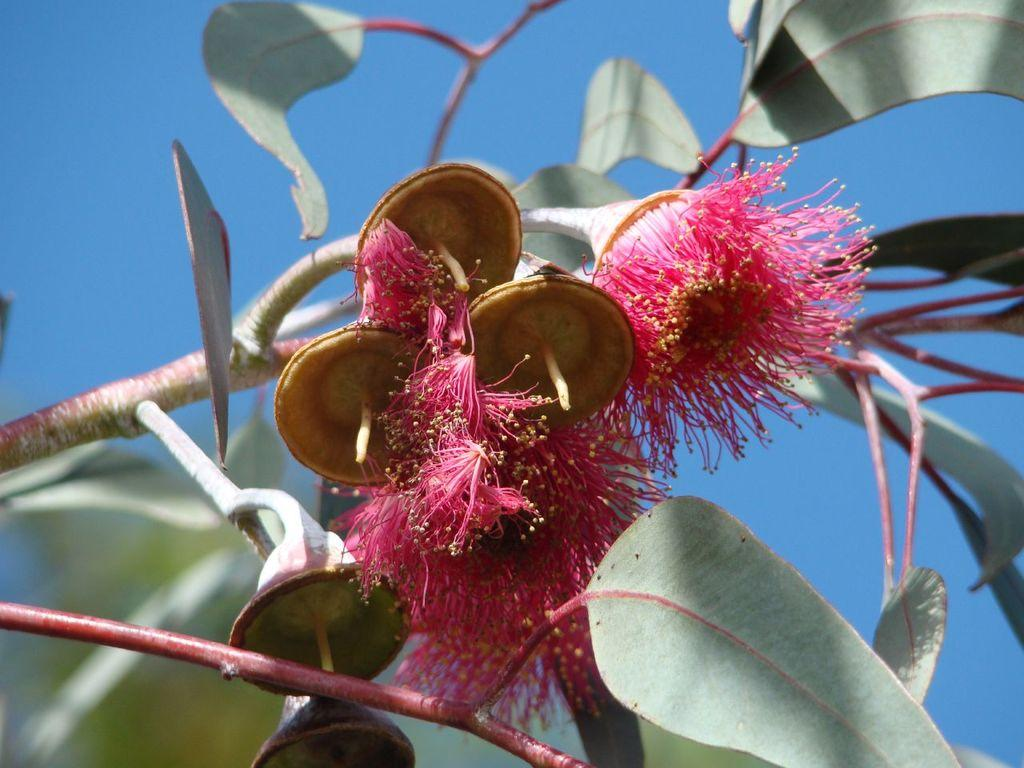What type of plant life is visible in the image? There are flowers, stems, and leaves in the image. What can be seen in the background of the image? The background of the image includes the sky. What is the color of the sky in the image? The sky is blue in color. What type of battle is taking place in the image? There is no battle present in the image; it features flowers, stems, and leaves with a blue sky in the background. Can you see any tubs or trucks in the image? There are no tubs or trucks present in the image. 